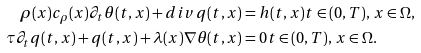<formula> <loc_0><loc_0><loc_500><loc_500>\rho ( x ) c _ { \rho } ( x ) \partial _ { t } \theta ( t , x ) + d i v \, q ( t , x ) & = h ( t , x ) t \in ( 0 , T ) , \, x \in \Omega , \\ \tau \partial _ { t } q ( t , x ) + q ( t , x ) + \lambda ( x ) \nabla \theta ( t , x ) & = 0 t \in ( 0 , T ) , \, x \in \Omega .</formula> 